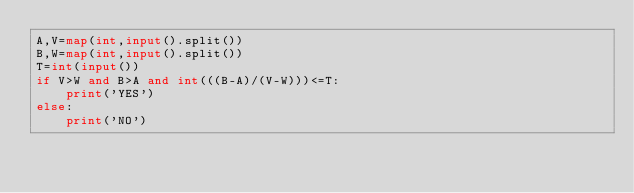<code> <loc_0><loc_0><loc_500><loc_500><_Python_>A,V=map(int,input().split())
B,W=map(int,input().split())
T=int(input())
if V>W and B>A and int(((B-A)/(V-W)))<=T:
    print('YES')
else:
    print('NO')</code> 